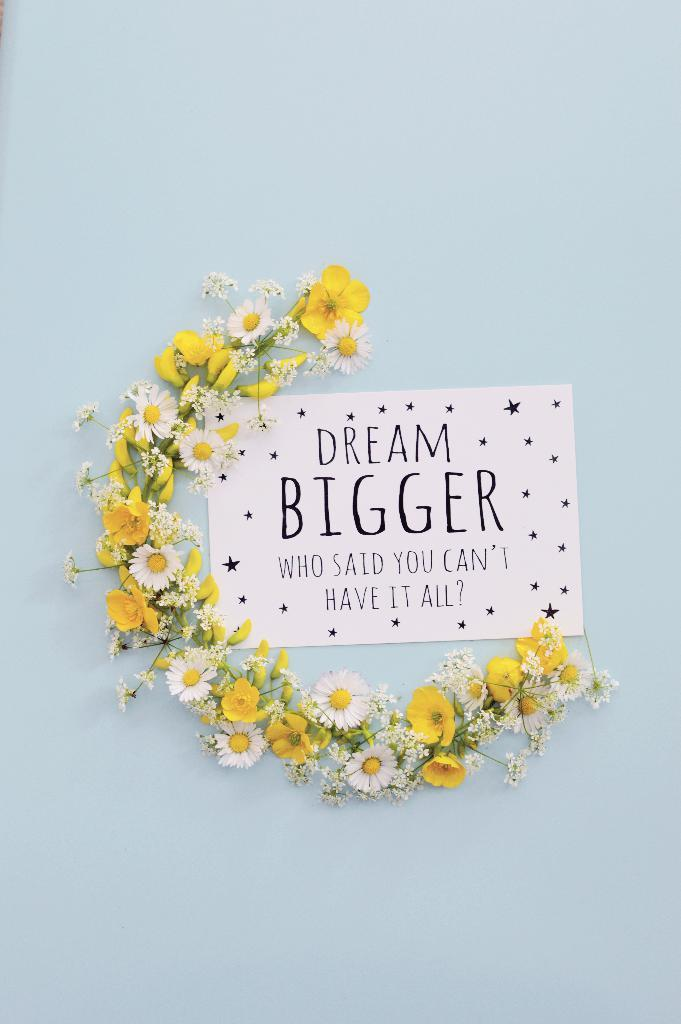What is located in the foreground of the image? There is a wall in the foreground of the image. What is on the wall? There is a poster on the wall. How is the poster decorated or adorned? A garland is placed semicircle around the poster. What type of crayon is being used to draw on the poster in the image? There is no crayon or drawing on the poster in the image; it only features a garland placed around it. 